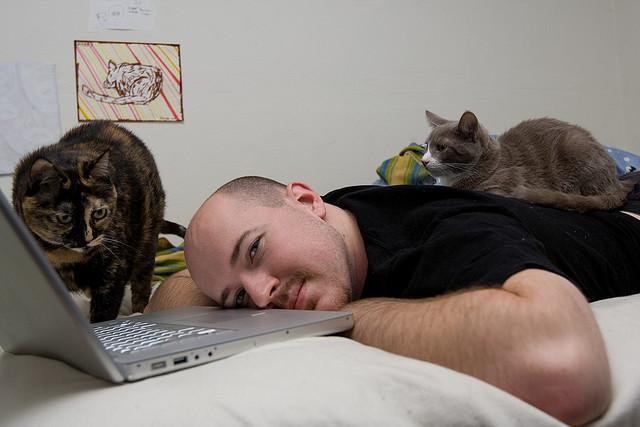How many mammals area shown?
Indicate the correct response by choosing from the four available options to answer the question.
Options: One, ten, three, two. Three. 